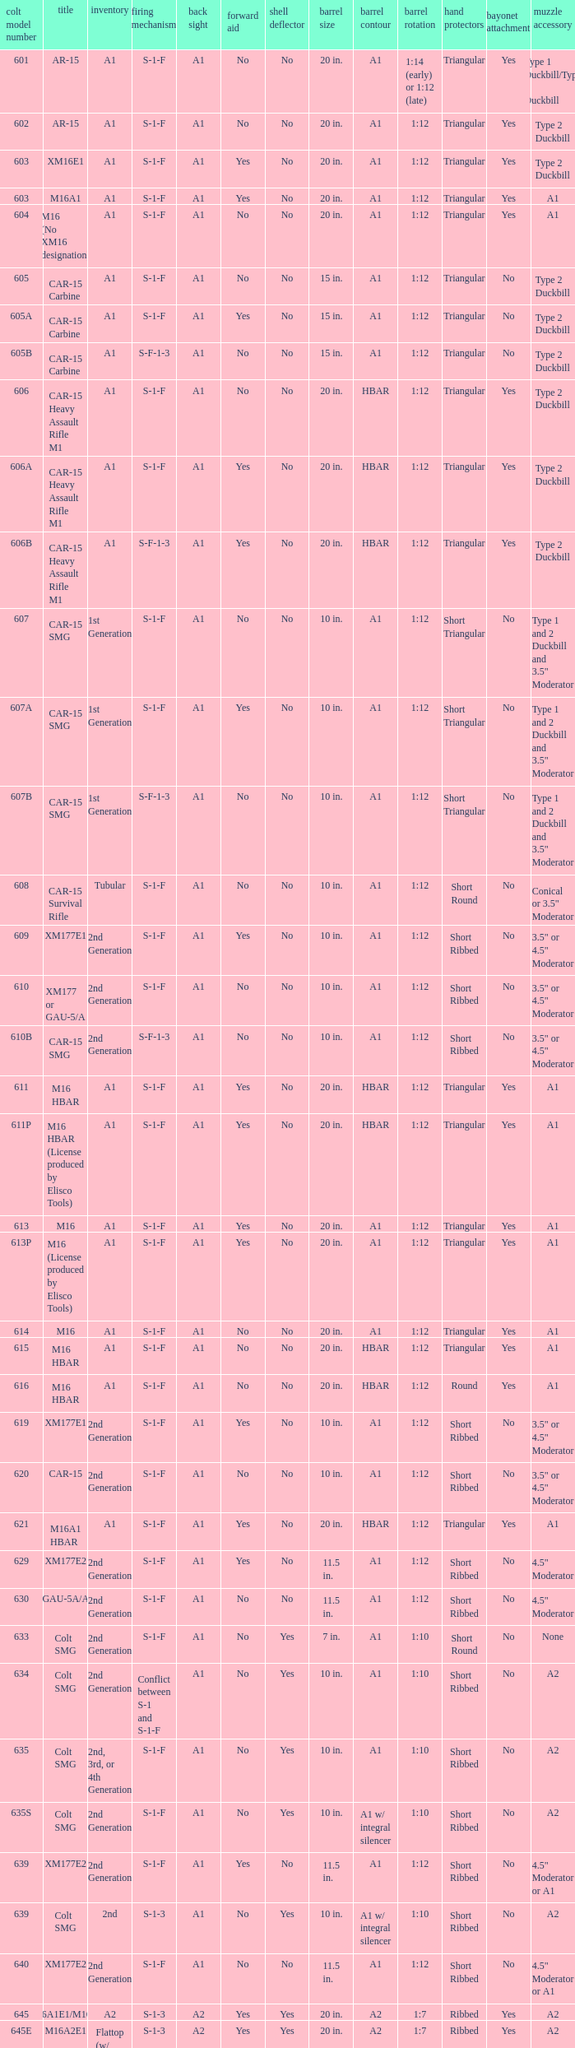What is the rear sight in the Cole model no. 735? A1 or A2. 